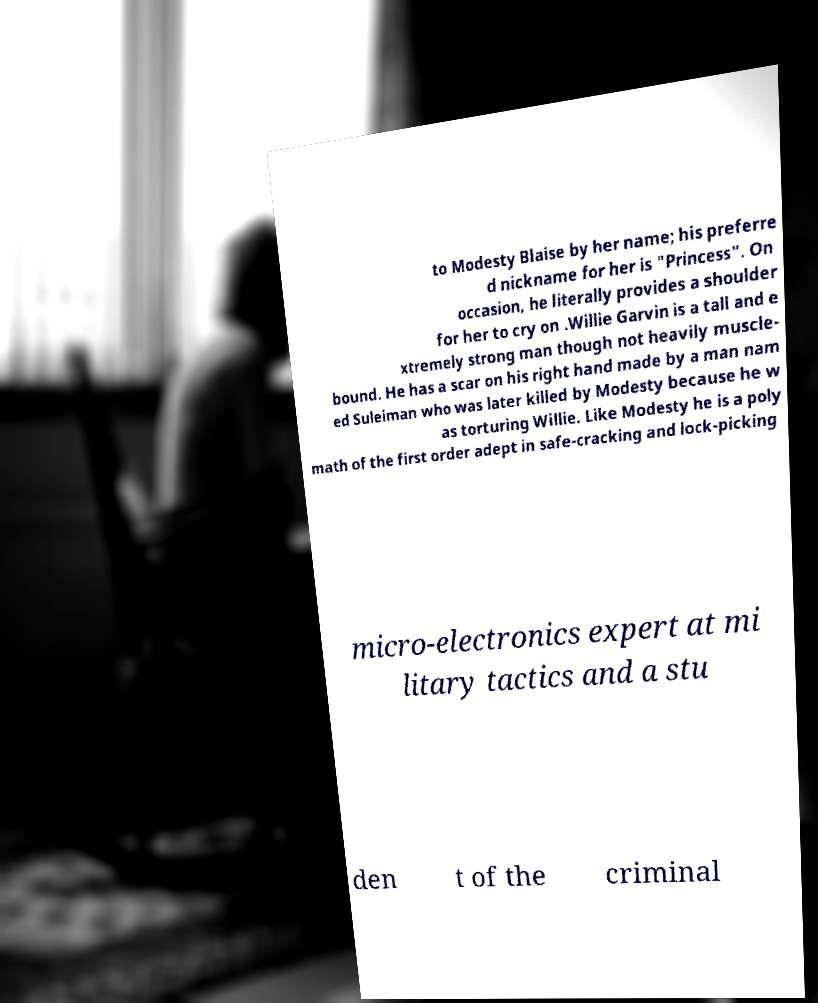I need the written content from this picture converted into text. Can you do that? to Modesty Blaise by her name; his preferre d nickname for her is "Princess". On occasion, he literally provides a shoulder for her to cry on .Willie Garvin is a tall and e xtremely strong man though not heavily muscle- bound. He has a scar on his right hand made by a man nam ed Suleiman who was later killed by Modesty because he w as torturing Willie. Like Modesty he is a poly math of the first order adept in safe-cracking and lock-picking micro-electronics expert at mi litary tactics and a stu den t of the criminal 